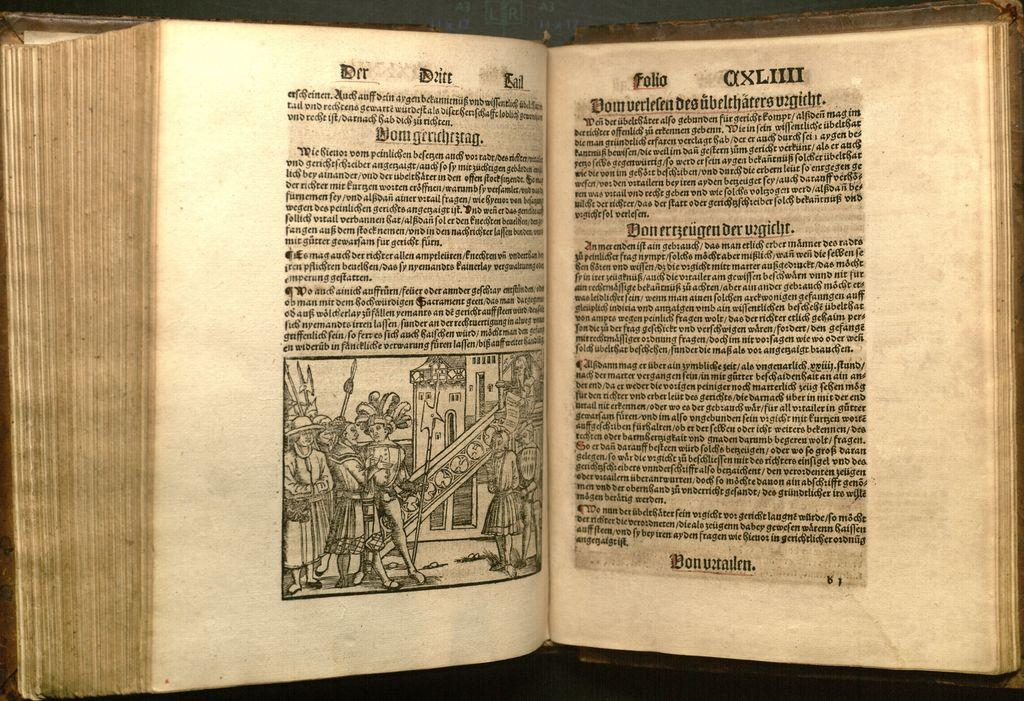<image>
Share a concise interpretation of the image provided. the number 4 is on the right side of the book in roman numeral form 